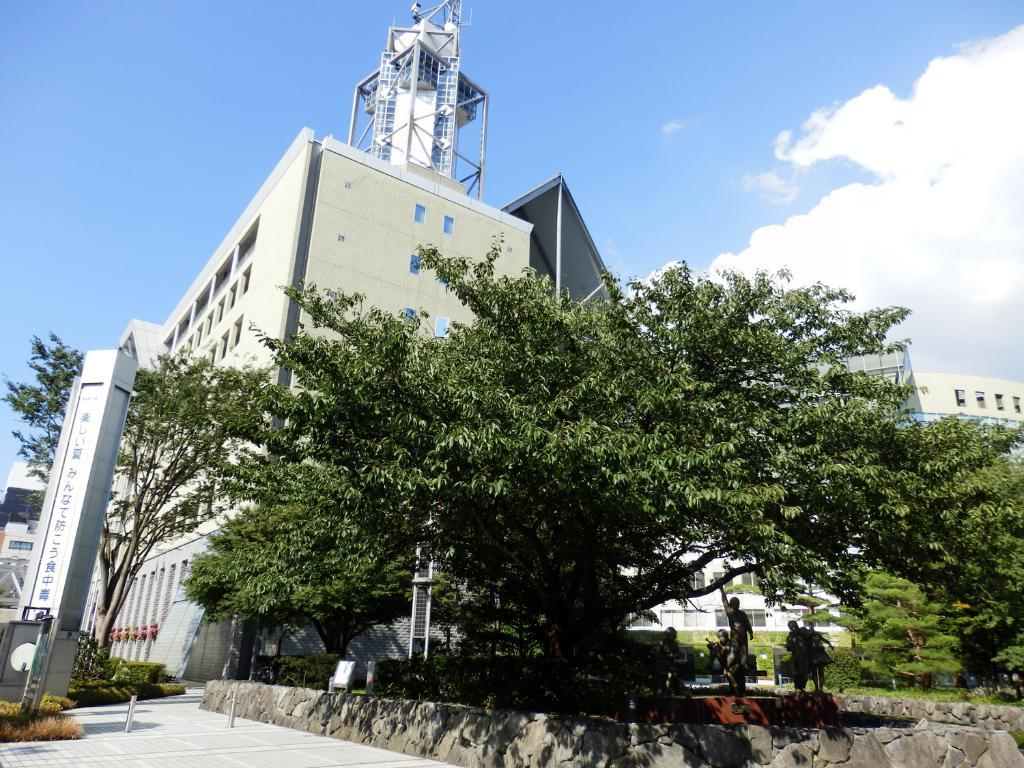What is located in the middle of the image? There are statues in the middle of the image. What type of vegetation is behind the statues? There are plants and trees behind the statues. What structures can be seen at the top of the image? There are buildings visible at the top of the image. What is present in the sky in the image? Clouds are present in the image. What part of the natural environment is visible in the image? The sky is visible in the image. What type of wax is used to create the statues in the image? There is no information about the material used to create the statues in the image, so we cannot determine if wax was used. 